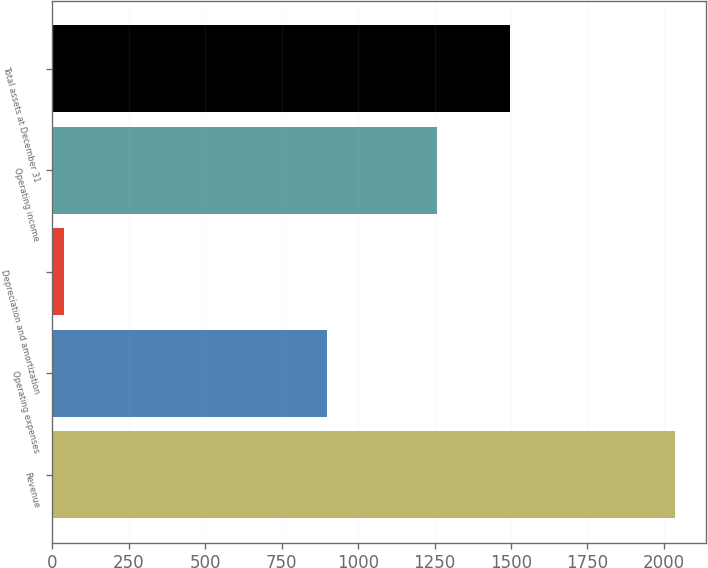<chart> <loc_0><loc_0><loc_500><loc_500><bar_chart><fcel>Revenue<fcel>Operating expenses<fcel>Depreciation and amortization<fcel>Operating income<fcel>Total assets at December 31<nl><fcel>2037.1<fcel>898.7<fcel>39.5<fcel>1259.5<fcel>1497.7<nl></chart> 